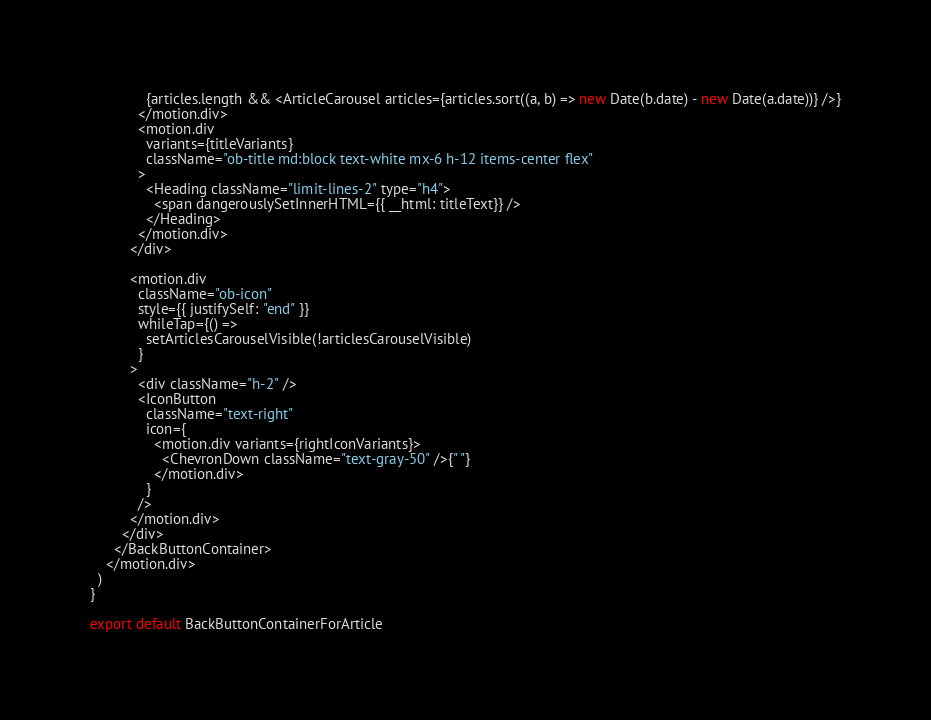<code> <loc_0><loc_0><loc_500><loc_500><_JavaScript_>              {articles.length && <ArticleCarousel articles={articles.sort((a, b) => new Date(b.date) - new Date(a.date))} />}
            </motion.div>
            <motion.div
              variants={titleVariants}
              className="ob-title md:block text-white mx-6 h-12 items-center flex"
            >
              <Heading className="limit-lines-2" type="h4">
                <span dangerouslySetInnerHTML={{ __html: titleText}} />
              </Heading>
            </motion.div>
          </div>

          <motion.div
            className="ob-icon"
            style={{ justifySelf: "end" }}
            whileTap={() =>
              setArticlesCarouselVisible(!articlesCarouselVisible)
            }
          >
            <div className="h-2" />
            <IconButton
              className="text-right"
              icon={
                <motion.div variants={rightIconVariants}>
                  <ChevronDown className="text-gray-50" />{" "}
                </motion.div>
              }
            />
          </motion.div>
        </div>
      </BackButtonContainer>
    </motion.div>
  )
}

export default BackButtonContainerForArticle
</code> 